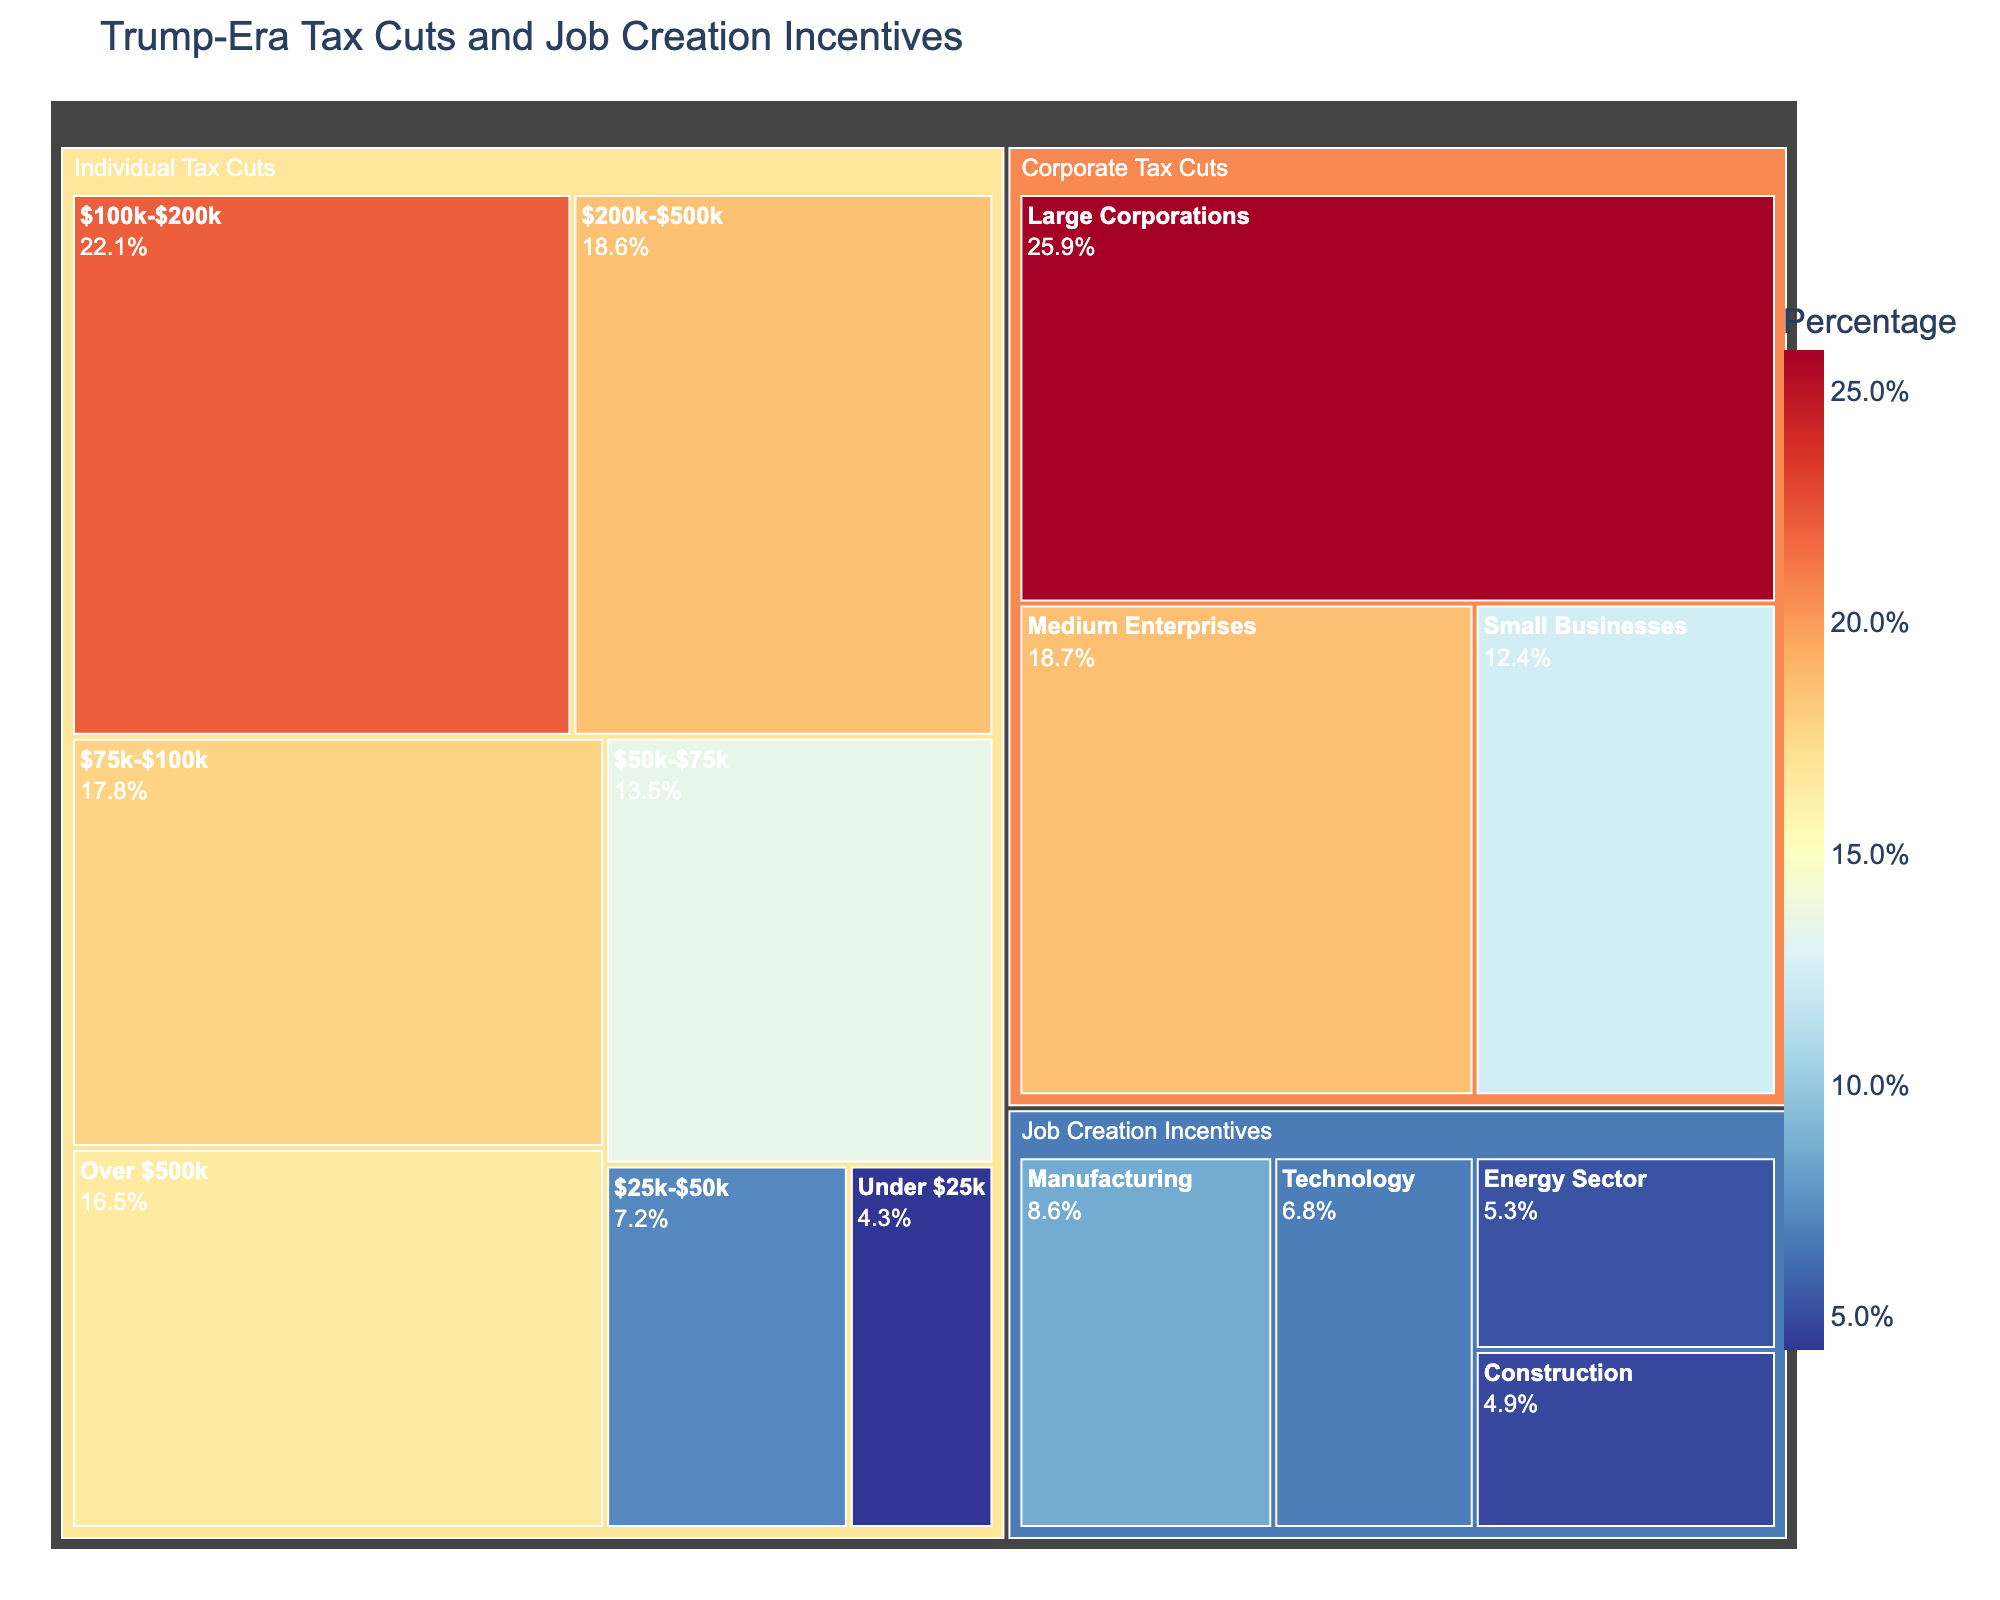What is the title of the figure? The title of the figure is typically displayed at the top, serving as an introduction to its contents. In this case, it summarizes the focus of the data.
Answer: Trump-Era Tax Cuts and Job Creation Incentives How much percentage do individual tax cuts for the $100k-$200k income bracket represent? Look for the subcategory labeled "$100k-$200k" under "Individual Tax Cuts" and read the percentage value associated with it.
Answer: 22.1% Which subcategory has the highest value in the Corporate Tax Cuts category? Identify all subcategories under "Corporate Tax Cuts" and compare their values to find the one with the highest percentage.
Answer: Large Corporations What is the combined value of tax cuts for income brackets below $75k in the Individual Tax Cuts category? Sum the values of the subcategories "Under $25k," "$25k-$50k," and "$50k-$75k" in the "Individual Tax Cuts" category: 4.3 + 7.2 + 13.5.
Answer: 25.0 Are job creation incentives larger for the Technology sector or the Construction sector? Compare the values of the subcategories "Technology" and "Construction" under "Job Creation Incentives."
Answer: Technology What is the total value of individual tax cuts provided? Sum the values of all subcategories under "Individual Tax Cuts": 4.3 + 7.2 + 13.5 + 17.8 + 22.1 + 18.6 + 16.5.
Answer: 100.0 Which category contributes more to the total value, Individual Tax Cuts or Corporate Tax Cuts? Calculate the sum of the values in each category. Compare the sum of "Individual Tax Cuts" (100.0) and "Corporate Tax Cuts" (12.4 + 18.7 + 25.9).
Answer: Individual Tax Cuts How does the value of tax cuts for the $75k-$100k income bracket compare to tax cuts for Small Businesses? Compare the values for the subcategories in question: "$75k-$100k" under "Individual Tax Cuts" and "Small Businesses" under "Corporate Tax Cuts."
Answer: $75k-$100k is higher What percentage of job creation incentives is directed toward the Energy Sector? Look for the percentage value of the "Energy Sector" subcategory under "Job Creation Incentives."
Answer: 5.3% Which has a larger total value, job creation incentives or corporate tax cuts? Sum the values of the subcategories under "Job Creation Incentives" (8.6 + 6.8 + 5.3 + 4.9) and compare it to the sum of "Corporate Tax Cuts" (12.4 + 18.7 + 25.9).
Answer: Corporate Tax Cuts 